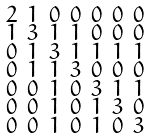Convert formula to latex. <formula><loc_0><loc_0><loc_500><loc_500>\begin{smallmatrix} 2 & 1 & 0 & 0 & 0 & 0 & 0 \\ 1 & 3 & 1 & 1 & 0 & 0 & 0 \\ 0 & 1 & 3 & 1 & 1 & 1 & 1 \\ 0 & 1 & 1 & 3 & 0 & 0 & 0 \\ 0 & 0 & 1 & 0 & 3 & 1 & 1 \\ 0 & 0 & 1 & 0 & 1 & 3 & 0 \\ 0 & 0 & 1 & 0 & 1 & 0 & 3 \end{smallmatrix}</formula> 